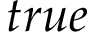<formula> <loc_0><loc_0><loc_500><loc_500>t r u e</formula> 